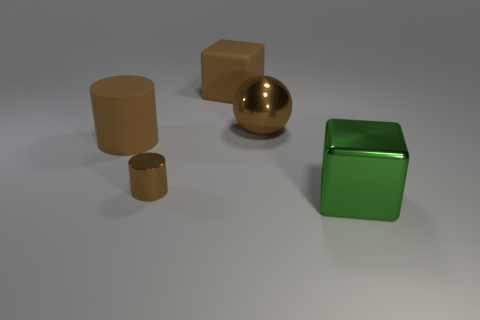Is the color of the rubber block the same as the large ball?
Your response must be concise. Yes. There is a big thing that is the same shape as the tiny brown thing; what is its color?
Your answer should be compact. Brown. What is the shape of the small thing that is the same color as the big cylinder?
Ensure brevity in your answer.  Cylinder. There is a large matte object that is behind the big metal thing that is behind the big rubber cylinder that is left of the large green metallic cube; what is its color?
Provide a succinct answer. Brown. Is the shape of the big metal thing left of the shiny block the same as  the small object?
Keep it short and to the point. No. There is a sphere that is the same size as the matte cube; what is its color?
Provide a succinct answer. Brown. How many small shiny things are there?
Offer a terse response. 1. Is the big cube that is in front of the tiny metallic cylinder made of the same material as the large ball?
Ensure brevity in your answer.  Yes. There is a brown thing that is to the right of the tiny metal object and in front of the matte cube; what is its material?
Give a very brief answer. Metal. What is the size of the metal cylinder that is the same color as the rubber cube?
Ensure brevity in your answer.  Small. 